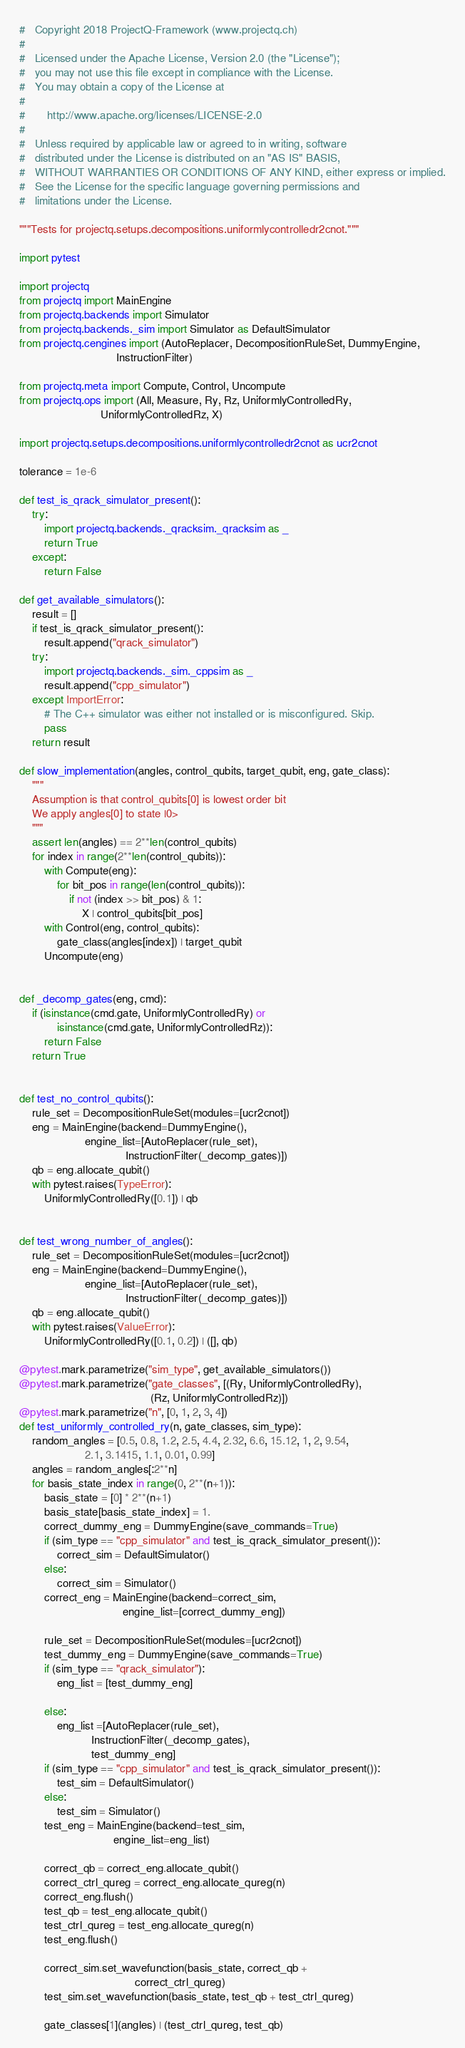Convert code to text. <code><loc_0><loc_0><loc_500><loc_500><_Python_>#   Copyright 2018 ProjectQ-Framework (www.projectq.ch)
#
#   Licensed under the Apache License, Version 2.0 (the "License");
#   you may not use this file except in compliance with the License.
#   You may obtain a copy of the License at
#
#       http://www.apache.org/licenses/LICENSE-2.0
#
#   Unless required by applicable law or agreed to in writing, software
#   distributed under the License is distributed on an "AS IS" BASIS,
#   WITHOUT WARRANTIES OR CONDITIONS OF ANY KIND, either express or implied.
#   See the License for the specific language governing permissions and
#   limitations under the License.

"""Tests for projectq.setups.decompositions.uniformlycontrolledr2cnot."""

import pytest

import projectq
from projectq import MainEngine
from projectq.backends import Simulator
from projectq.backends._sim import Simulator as DefaultSimulator
from projectq.cengines import (AutoReplacer, DecompositionRuleSet, DummyEngine,
                               InstructionFilter)

from projectq.meta import Compute, Control, Uncompute
from projectq.ops import (All, Measure, Ry, Rz, UniformlyControlledRy,
                          UniformlyControlledRz, X)

import projectq.setups.decompositions.uniformlycontrolledr2cnot as ucr2cnot

tolerance = 1e-6

def test_is_qrack_simulator_present():
    try:
        import projectq.backends._qracksim._qracksim as _
        return True
    except:
        return False

def get_available_simulators():
    result = []
    if test_is_qrack_simulator_present():
        result.append("qrack_simulator")
    try:
        import projectq.backends._sim._cppsim as _
        result.append("cpp_simulator")
    except ImportError:
        # The C++ simulator was either not installed or is misconfigured. Skip.
        pass
    return result

def slow_implementation(angles, control_qubits, target_qubit, eng, gate_class):
    """
    Assumption is that control_qubits[0] is lowest order bit
    We apply angles[0] to state |0>
    """
    assert len(angles) == 2**len(control_qubits)
    for index in range(2**len(control_qubits)):
        with Compute(eng):
            for bit_pos in range(len(control_qubits)):
                if not (index >> bit_pos) & 1:
                    X | control_qubits[bit_pos]
        with Control(eng, control_qubits):
            gate_class(angles[index]) | target_qubit
        Uncompute(eng)


def _decomp_gates(eng, cmd):
    if (isinstance(cmd.gate, UniformlyControlledRy) or
            isinstance(cmd.gate, UniformlyControlledRz)):
        return False
    return True


def test_no_control_qubits():
    rule_set = DecompositionRuleSet(modules=[ucr2cnot])
    eng = MainEngine(backend=DummyEngine(),
                     engine_list=[AutoReplacer(rule_set),
                                  InstructionFilter(_decomp_gates)])
    qb = eng.allocate_qubit()
    with pytest.raises(TypeError):
        UniformlyControlledRy([0.1]) | qb


def test_wrong_number_of_angles():
    rule_set = DecompositionRuleSet(modules=[ucr2cnot])
    eng = MainEngine(backend=DummyEngine(),
                     engine_list=[AutoReplacer(rule_set),
                                  InstructionFilter(_decomp_gates)])
    qb = eng.allocate_qubit()
    with pytest.raises(ValueError):
        UniformlyControlledRy([0.1, 0.2]) | ([], qb)

@pytest.mark.parametrize("sim_type", get_available_simulators())
@pytest.mark.parametrize("gate_classes", [(Ry, UniformlyControlledRy),
                                          (Rz, UniformlyControlledRz)])
@pytest.mark.parametrize("n", [0, 1, 2, 3, 4])
def test_uniformly_controlled_ry(n, gate_classes, sim_type):
    random_angles = [0.5, 0.8, 1.2, 2.5, 4.4, 2.32, 6.6, 15.12, 1, 2, 9.54,
                     2.1, 3.1415, 1.1, 0.01, 0.99]
    angles = random_angles[:2**n]
    for basis_state_index in range(0, 2**(n+1)):
        basis_state = [0] * 2**(n+1)
        basis_state[basis_state_index] = 1.
        correct_dummy_eng = DummyEngine(save_commands=True)
        if (sim_type == "cpp_simulator" and test_is_qrack_simulator_present()):
            correct_sim = DefaultSimulator()
        else:
            correct_sim = Simulator()
        correct_eng = MainEngine(backend=correct_sim,
                                 engine_list=[correct_dummy_eng])

        rule_set = DecompositionRuleSet(modules=[ucr2cnot])
        test_dummy_eng = DummyEngine(save_commands=True)
        if (sim_type == "qrack_simulator"):
            eng_list = [test_dummy_eng]
            
        else:
            eng_list =[AutoReplacer(rule_set),
                       InstructionFilter(_decomp_gates),
                       test_dummy_eng]
        if (sim_type == "cpp_simulator" and test_is_qrack_simulator_present()):
            test_sim = DefaultSimulator()
        else:
            test_sim = Simulator()
        test_eng = MainEngine(backend=test_sim,
                              engine_list=eng_list)

        correct_qb = correct_eng.allocate_qubit()
        correct_ctrl_qureg = correct_eng.allocate_qureg(n)
        correct_eng.flush()
        test_qb = test_eng.allocate_qubit()
        test_ctrl_qureg = test_eng.allocate_qureg(n)
        test_eng.flush()

        correct_sim.set_wavefunction(basis_state, correct_qb +
                                     correct_ctrl_qureg)
        test_sim.set_wavefunction(basis_state, test_qb + test_ctrl_qureg)

        gate_classes[1](angles) | (test_ctrl_qureg, test_qb)</code> 